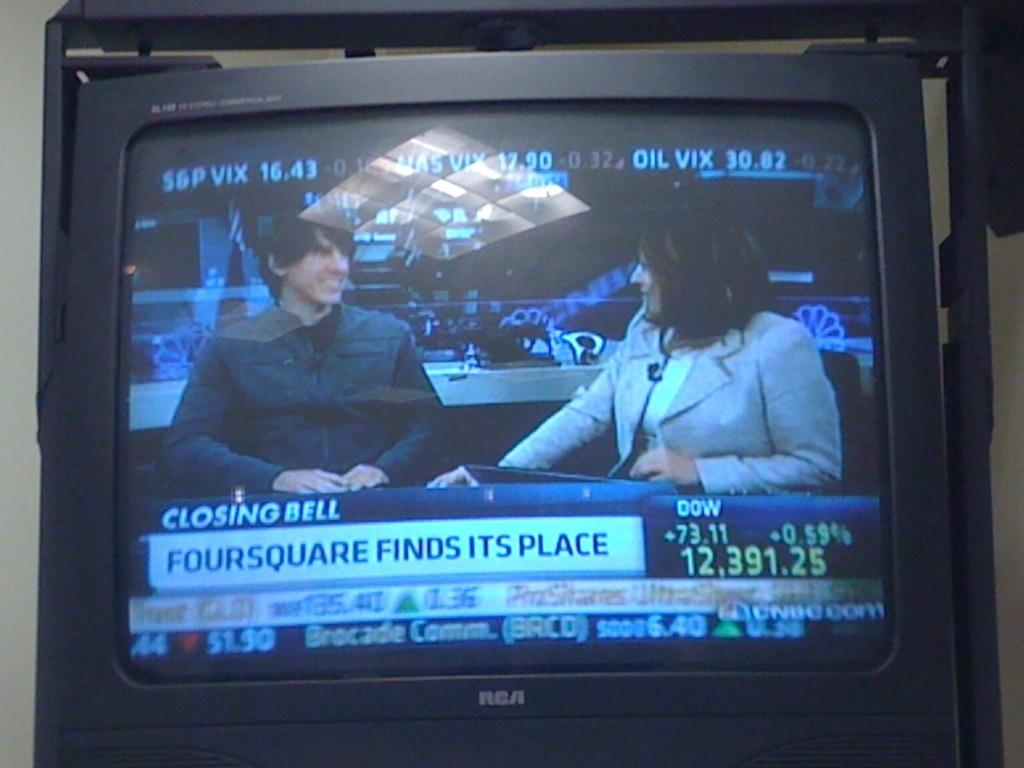Provide a one-sentence caption for the provided image. A TV shows a man and a woman talking and it says Closing Bell beneath them. 